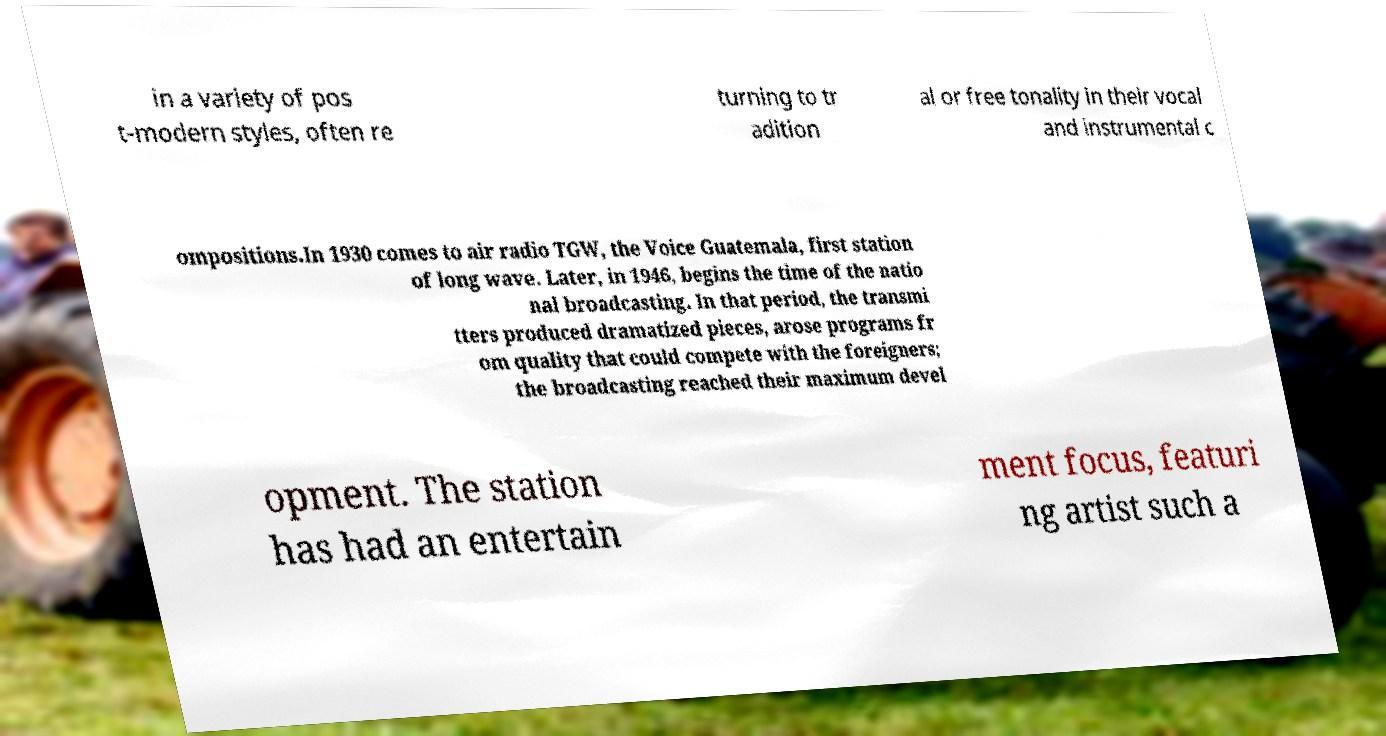For documentation purposes, I need the text within this image transcribed. Could you provide that? in a variety of pos t-modern styles, often re turning to tr adition al or free tonality in their vocal and instrumental c ompositions.In 1930 comes to air radio TGW, the Voice Guatemala, first station of long wave. Later, in 1946, begins the time of the natio nal broadcasting. In that period, the transmi tters produced dramatized pieces, arose programs fr om quality that could compete with the foreigners; the broadcasting reached their maximum devel opment. The station has had an entertain ment focus, featuri ng artist such a 